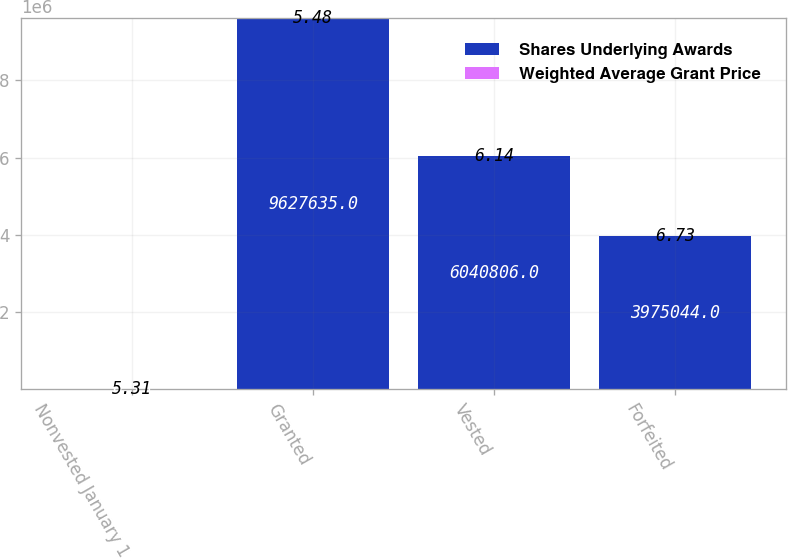<chart> <loc_0><loc_0><loc_500><loc_500><stacked_bar_chart><ecel><fcel>Nonvested January 1<fcel>Granted<fcel>Vested<fcel>Forfeited<nl><fcel>Shares Underlying Awards<fcel>6.73<fcel>9.62764e+06<fcel>6.04081e+06<fcel>3.97504e+06<nl><fcel>Weighted Average Grant Price<fcel>5.31<fcel>5.48<fcel>6.14<fcel>6.73<nl></chart> 